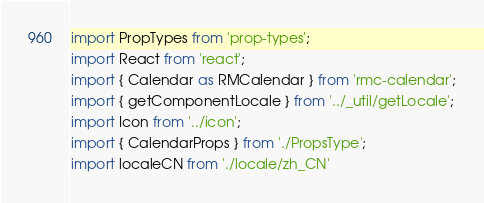<code> <loc_0><loc_0><loc_500><loc_500><_TypeScript_>import PropTypes from 'prop-types';
import React from 'react';
import { Calendar as RMCalendar } from 'rmc-calendar';
import { getComponentLocale } from '../_util/getLocale';
import Icon from '../icon';
import { CalendarProps } from './PropsType';
import localeCN from './locale/zh_CN'</code> 